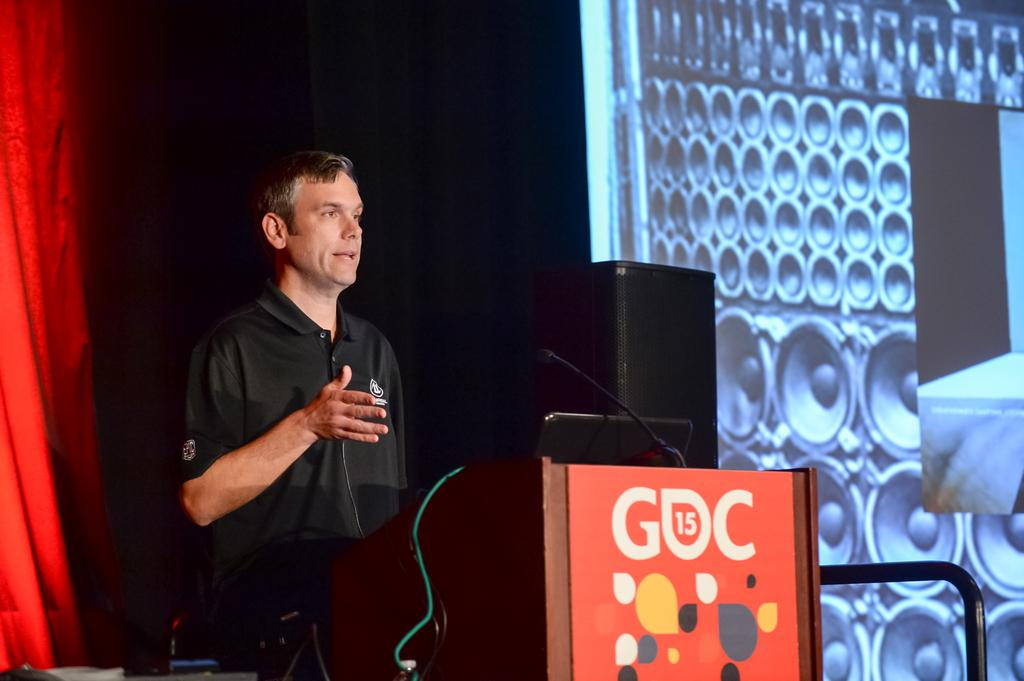What is the main object on the podium in the image? A laptop is present on the podium. What other items can be seen on the podium? A microphone is on the podium. What type of curtain is visible in the image? There is a red curtain in the image. Who might be speaking in the image? A speaker is visible in the image. What is the purpose of the screen in the image? The screen is likely used for displaying information or visuals during the speaker's presentation. What type of operation is being performed on the balloon in the image? There is no balloon present in the image, so no operation is being performed on it. What design elements can be seen on the speaker's clothing in the image? There is no information about the speaker's clothing in the image, so we cannot determine any design elements. 